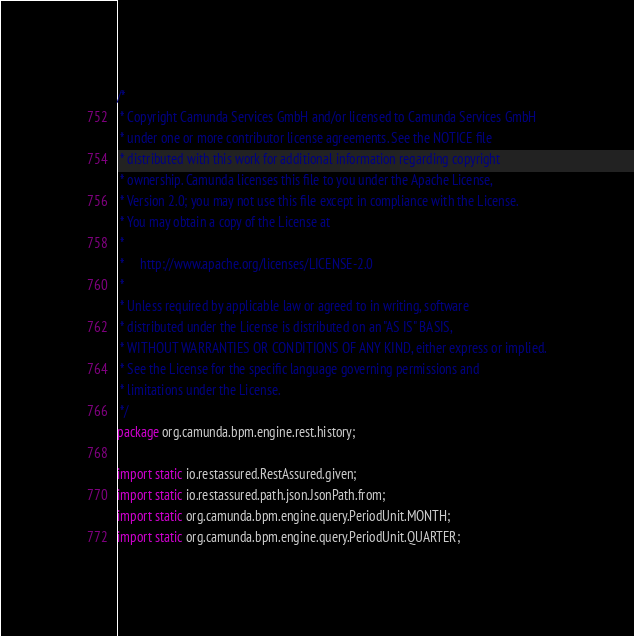Convert code to text. <code><loc_0><loc_0><loc_500><loc_500><_Java_>/*
 * Copyright Camunda Services GmbH and/or licensed to Camunda Services GmbH
 * under one or more contributor license agreements. See the NOTICE file
 * distributed with this work for additional information regarding copyright
 * ownership. Camunda licenses this file to you under the Apache License,
 * Version 2.0; you may not use this file except in compliance with the License.
 * You may obtain a copy of the License at
 *
 *     http://www.apache.org/licenses/LICENSE-2.0
 *
 * Unless required by applicable law or agreed to in writing, software
 * distributed under the License is distributed on an "AS IS" BASIS,
 * WITHOUT WARRANTIES OR CONDITIONS OF ANY KIND, either express or implied.
 * See the License for the specific language governing permissions and
 * limitations under the License.
 */
package org.camunda.bpm.engine.rest.history;

import static io.restassured.RestAssured.given;
import static io.restassured.path.json.JsonPath.from;
import static org.camunda.bpm.engine.query.PeriodUnit.MONTH;
import static org.camunda.bpm.engine.query.PeriodUnit.QUARTER;</code> 